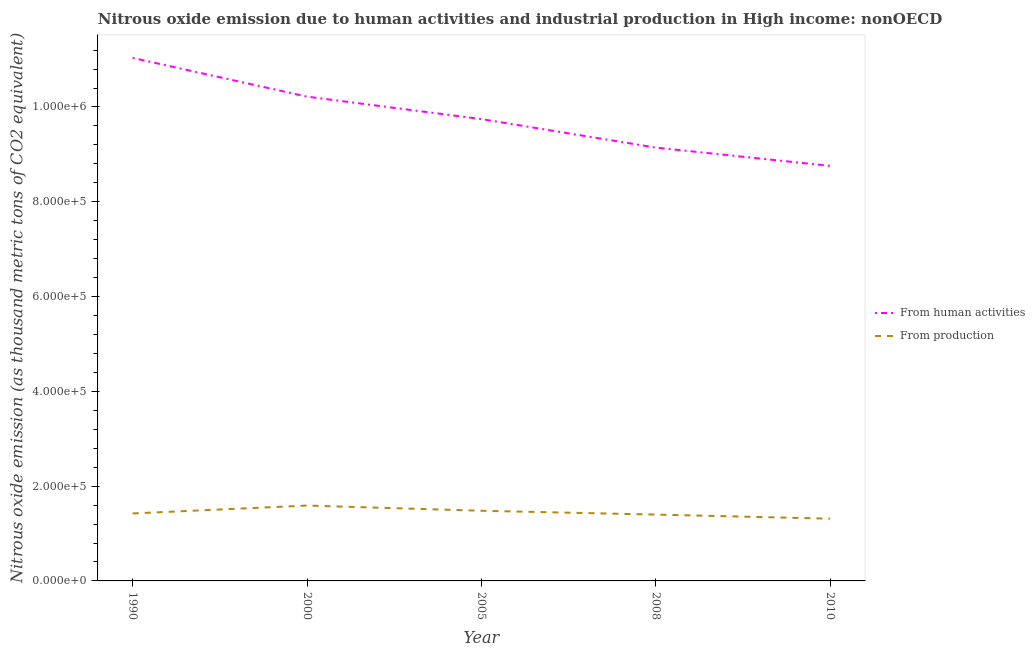Does the line corresponding to amount of emissions from human activities intersect with the line corresponding to amount of emissions generated from industries?
Make the answer very short. No. What is the amount of emissions generated from industries in 1990?
Give a very brief answer. 1.42e+05. Across all years, what is the maximum amount of emissions from human activities?
Your answer should be very brief. 1.10e+06. Across all years, what is the minimum amount of emissions from human activities?
Ensure brevity in your answer.  8.76e+05. In which year was the amount of emissions generated from industries maximum?
Your answer should be compact. 2000. What is the total amount of emissions generated from industries in the graph?
Offer a very short reply. 7.21e+05. What is the difference between the amount of emissions generated from industries in 2000 and that in 2008?
Offer a very short reply. 1.90e+04. What is the difference between the amount of emissions from human activities in 2010 and the amount of emissions generated from industries in 2000?
Offer a terse response. 7.17e+05. What is the average amount of emissions from human activities per year?
Your response must be concise. 9.78e+05. In the year 2000, what is the difference between the amount of emissions from human activities and amount of emissions generated from industries?
Provide a short and direct response. 8.63e+05. In how many years, is the amount of emissions generated from industries greater than 320000 thousand metric tons?
Make the answer very short. 0. What is the ratio of the amount of emissions generated from industries in 2000 to that in 2010?
Your answer should be very brief. 1.21. Is the difference between the amount of emissions generated from industries in 1990 and 2010 greater than the difference between the amount of emissions from human activities in 1990 and 2010?
Give a very brief answer. No. What is the difference between the highest and the second highest amount of emissions generated from industries?
Offer a very short reply. 1.10e+04. What is the difference between the highest and the lowest amount of emissions from human activities?
Offer a terse response. 2.28e+05. Does the amount of emissions from human activities monotonically increase over the years?
Provide a short and direct response. No. Is the amount of emissions from human activities strictly less than the amount of emissions generated from industries over the years?
Your answer should be very brief. No. How many lines are there?
Your answer should be compact. 2. Are the values on the major ticks of Y-axis written in scientific E-notation?
Ensure brevity in your answer.  Yes. Does the graph contain any zero values?
Your answer should be very brief. No. How many legend labels are there?
Provide a short and direct response. 2. How are the legend labels stacked?
Offer a very short reply. Vertical. What is the title of the graph?
Keep it short and to the point. Nitrous oxide emission due to human activities and industrial production in High income: nonOECD. Does "Exports" appear as one of the legend labels in the graph?
Your answer should be compact. No. What is the label or title of the Y-axis?
Your response must be concise. Nitrous oxide emission (as thousand metric tons of CO2 equivalent). What is the Nitrous oxide emission (as thousand metric tons of CO2 equivalent) of From human activities in 1990?
Your answer should be compact. 1.10e+06. What is the Nitrous oxide emission (as thousand metric tons of CO2 equivalent) of From production in 1990?
Keep it short and to the point. 1.42e+05. What is the Nitrous oxide emission (as thousand metric tons of CO2 equivalent) of From human activities in 2000?
Provide a short and direct response. 1.02e+06. What is the Nitrous oxide emission (as thousand metric tons of CO2 equivalent) of From production in 2000?
Offer a terse response. 1.59e+05. What is the Nitrous oxide emission (as thousand metric tons of CO2 equivalent) in From human activities in 2005?
Offer a very short reply. 9.74e+05. What is the Nitrous oxide emission (as thousand metric tons of CO2 equivalent) of From production in 2005?
Ensure brevity in your answer.  1.48e+05. What is the Nitrous oxide emission (as thousand metric tons of CO2 equivalent) in From human activities in 2008?
Offer a very short reply. 9.14e+05. What is the Nitrous oxide emission (as thousand metric tons of CO2 equivalent) in From production in 2008?
Offer a terse response. 1.40e+05. What is the Nitrous oxide emission (as thousand metric tons of CO2 equivalent) in From human activities in 2010?
Your answer should be very brief. 8.76e+05. What is the Nitrous oxide emission (as thousand metric tons of CO2 equivalent) in From production in 2010?
Provide a succinct answer. 1.31e+05. Across all years, what is the maximum Nitrous oxide emission (as thousand metric tons of CO2 equivalent) of From human activities?
Keep it short and to the point. 1.10e+06. Across all years, what is the maximum Nitrous oxide emission (as thousand metric tons of CO2 equivalent) in From production?
Ensure brevity in your answer.  1.59e+05. Across all years, what is the minimum Nitrous oxide emission (as thousand metric tons of CO2 equivalent) in From human activities?
Provide a short and direct response. 8.76e+05. Across all years, what is the minimum Nitrous oxide emission (as thousand metric tons of CO2 equivalent) of From production?
Give a very brief answer. 1.31e+05. What is the total Nitrous oxide emission (as thousand metric tons of CO2 equivalent) of From human activities in the graph?
Offer a terse response. 4.89e+06. What is the total Nitrous oxide emission (as thousand metric tons of CO2 equivalent) of From production in the graph?
Provide a succinct answer. 7.21e+05. What is the difference between the Nitrous oxide emission (as thousand metric tons of CO2 equivalent) of From human activities in 1990 and that in 2000?
Offer a terse response. 8.17e+04. What is the difference between the Nitrous oxide emission (as thousand metric tons of CO2 equivalent) of From production in 1990 and that in 2000?
Your response must be concise. -1.66e+04. What is the difference between the Nitrous oxide emission (as thousand metric tons of CO2 equivalent) in From human activities in 1990 and that in 2005?
Offer a very short reply. 1.29e+05. What is the difference between the Nitrous oxide emission (as thousand metric tons of CO2 equivalent) of From production in 1990 and that in 2005?
Your answer should be very brief. -5648.4. What is the difference between the Nitrous oxide emission (as thousand metric tons of CO2 equivalent) of From human activities in 1990 and that in 2008?
Offer a terse response. 1.89e+05. What is the difference between the Nitrous oxide emission (as thousand metric tons of CO2 equivalent) of From production in 1990 and that in 2008?
Your response must be concise. 2410.2. What is the difference between the Nitrous oxide emission (as thousand metric tons of CO2 equivalent) of From human activities in 1990 and that in 2010?
Ensure brevity in your answer.  2.28e+05. What is the difference between the Nitrous oxide emission (as thousand metric tons of CO2 equivalent) in From production in 1990 and that in 2010?
Your answer should be very brief. 1.11e+04. What is the difference between the Nitrous oxide emission (as thousand metric tons of CO2 equivalent) of From human activities in 2000 and that in 2005?
Make the answer very short. 4.74e+04. What is the difference between the Nitrous oxide emission (as thousand metric tons of CO2 equivalent) in From production in 2000 and that in 2005?
Make the answer very short. 1.10e+04. What is the difference between the Nitrous oxide emission (as thousand metric tons of CO2 equivalent) of From human activities in 2000 and that in 2008?
Your answer should be very brief. 1.08e+05. What is the difference between the Nitrous oxide emission (as thousand metric tons of CO2 equivalent) in From production in 2000 and that in 2008?
Offer a very short reply. 1.90e+04. What is the difference between the Nitrous oxide emission (as thousand metric tons of CO2 equivalent) in From human activities in 2000 and that in 2010?
Offer a terse response. 1.46e+05. What is the difference between the Nitrous oxide emission (as thousand metric tons of CO2 equivalent) of From production in 2000 and that in 2010?
Your answer should be very brief. 2.77e+04. What is the difference between the Nitrous oxide emission (as thousand metric tons of CO2 equivalent) in From human activities in 2005 and that in 2008?
Keep it short and to the point. 6.02e+04. What is the difference between the Nitrous oxide emission (as thousand metric tons of CO2 equivalent) of From production in 2005 and that in 2008?
Offer a terse response. 8058.6. What is the difference between the Nitrous oxide emission (as thousand metric tons of CO2 equivalent) of From human activities in 2005 and that in 2010?
Provide a short and direct response. 9.88e+04. What is the difference between the Nitrous oxide emission (as thousand metric tons of CO2 equivalent) in From production in 2005 and that in 2010?
Make the answer very short. 1.67e+04. What is the difference between the Nitrous oxide emission (as thousand metric tons of CO2 equivalent) in From human activities in 2008 and that in 2010?
Your answer should be compact. 3.86e+04. What is the difference between the Nitrous oxide emission (as thousand metric tons of CO2 equivalent) in From production in 2008 and that in 2010?
Your answer should be very brief. 8647.3. What is the difference between the Nitrous oxide emission (as thousand metric tons of CO2 equivalent) in From human activities in 1990 and the Nitrous oxide emission (as thousand metric tons of CO2 equivalent) in From production in 2000?
Your response must be concise. 9.45e+05. What is the difference between the Nitrous oxide emission (as thousand metric tons of CO2 equivalent) of From human activities in 1990 and the Nitrous oxide emission (as thousand metric tons of CO2 equivalent) of From production in 2005?
Make the answer very short. 9.55e+05. What is the difference between the Nitrous oxide emission (as thousand metric tons of CO2 equivalent) in From human activities in 1990 and the Nitrous oxide emission (as thousand metric tons of CO2 equivalent) in From production in 2008?
Offer a very short reply. 9.64e+05. What is the difference between the Nitrous oxide emission (as thousand metric tons of CO2 equivalent) in From human activities in 1990 and the Nitrous oxide emission (as thousand metric tons of CO2 equivalent) in From production in 2010?
Provide a succinct answer. 9.72e+05. What is the difference between the Nitrous oxide emission (as thousand metric tons of CO2 equivalent) of From human activities in 2000 and the Nitrous oxide emission (as thousand metric tons of CO2 equivalent) of From production in 2005?
Your answer should be very brief. 8.74e+05. What is the difference between the Nitrous oxide emission (as thousand metric tons of CO2 equivalent) of From human activities in 2000 and the Nitrous oxide emission (as thousand metric tons of CO2 equivalent) of From production in 2008?
Offer a terse response. 8.82e+05. What is the difference between the Nitrous oxide emission (as thousand metric tons of CO2 equivalent) in From human activities in 2000 and the Nitrous oxide emission (as thousand metric tons of CO2 equivalent) in From production in 2010?
Provide a short and direct response. 8.90e+05. What is the difference between the Nitrous oxide emission (as thousand metric tons of CO2 equivalent) of From human activities in 2005 and the Nitrous oxide emission (as thousand metric tons of CO2 equivalent) of From production in 2008?
Offer a very short reply. 8.34e+05. What is the difference between the Nitrous oxide emission (as thousand metric tons of CO2 equivalent) of From human activities in 2005 and the Nitrous oxide emission (as thousand metric tons of CO2 equivalent) of From production in 2010?
Your response must be concise. 8.43e+05. What is the difference between the Nitrous oxide emission (as thousand metric tons of CO2 equivalent) of From human activities in 2008 and the Nitrous oxide emission (as thousand metric tons of CO2 equivalent) of From production in 2010?
Offer a very short reply. 7.83e+05. What is the average Nitrous oxide emission (as thousand metric tons of CO2 equivalent) of From human activities per year?
Your answer should be very brief. 9.78e+05. What is the average Nitrous oxide emission (as thousand metric tons of CO2 equivalent) of From production per year?
Offer a terse response. 1.44e+05. In the year 1990, what is the difference between the Nitrous oxide emission (as thousand metric tons of CO2 equivalent) of From human activities and Nitrous oxide emission (as thousand metric tons of CO2 equivalent) of From production?
Your answer should be compact. 9.61e+05. In the year 2000, what is the difference between the Nitrous oxide emission (as thousand metric tons of CO2 equivalent) in From human activities and Nitrous oxide emission (as thousand metric tons of CO2 equivalent) in From production?
Keep it short and to the point. 8.63e+05. In the year 2005, what is the difference between the Nitrous oxide emission (as thousand metric tons of CO2 equivalent) in From human activities and Nitrous oxide emission (as thousand metric tons of CO2 equivalent) in From production?
Your answer should be very brief. 8.26e+05. In the year 2008, what is the difference between the Nitrous oxide emission (as thousand metric tons of CO2 equivalent) of From human activities and Nitrous oxide emission (as thousand metric tons of CO2 equivalent) of From production?
Offer a very short reply. 7.74e+05. In the year 2010, what is the difference between the Nitrous oxide emission (as thousand metric tons of CO2 equivalent) in From human activities and Nitrous oxide emission (as thousand metric tons of CO2 equivalent) in From production?
Your answer should be very brief. 7.44e+05. What is the ratio of the Nitrous oxide emission (as thousand metric tons of CO2 equivalent) of From production in 1990 to that in 2000?
Provide a succinct answer. 0.9. What is the ratio of the Nitrous oxide emission (as thousand metric tons of CO2 equivalent) of From human activities in 1990 to that in 2005?
Keep it short and to the point. 1.13. What is the ratio of the Nitrous oxide emission (as thousand metric tons of CO2 equivalent) of From production in 1990 to that in 2005?
Offer a terse response. 0.96. What is the ratio of the Nitrous oxide emission (as thousand metric tons of CO2 equivalent) of From human activities in 1990 to that in 2008?
Offer a very short reply. 1.21. What is the ratio of the Nitrous oxide emission (as thousand metric tons of CO2 equivalent) in From production in 1990 to that in 2008?
Keep it short and to the point. 1.02. What is the ratio of the Nitrous oxide emission (as thousand metric tons of CO2 equivalent) of From human activities in 1990 to that in 2010?
Provide a succinct answer. 1.26. What is the ratio of the Nitrous oxide emission (as thousand metric tons of CO2 equivalent) of From production in 1990 to that in 2010?
Offer a terse response. 1.08. What is the ratio of the Nitrous oxide emission (as thousand metric tons of CO2 equivalent) of From human activities in 2000 to that in 2005?
Your answer should be compact. 1.05. What is the ratio of the Nitrous oxide emission (as thousand metric tons of CO2 equivalent) in From production in 2000 to that in 2005?
Your answer should be compact. 1.07. What is the ratio of the Nitrous oxide emission (as thousand metric tons of CO2 equivalent) in From human activities in 2000 to that in 2008?
Your response must be concise. 1.12. What is the ratio of the Nitrous oxide emission (as thousand metric tons of CO2 equivalent) in From production in 2000 to that in 2008?
Your answer should be very brief. 1.14. What is the ratio of the Nitrous oxide emission (as thousand metric tons of CO2 equivalent) in From human activities in 2000 to that in 2010?
Your answer should be compact. 1.17. What is the ratio of the Nitrous oxide emission (as thousand metric tons of CO2 equivalent) in From production in 2000 to that in 2010?
Provide a succinct answer. 1.21. What is the ratio of the Nitrous oxide emission (as thousand metric tons of CO2 equivalent) in From human activities in 2005 to that in 2008?
Your response must be concise. 1.07. What is the ratio of the Nitrous oxide emission (as thousand metric tons of CO2 equivalent) of From production in 2005 to that in 2008?
Your answer should be compact. 1.06. What is the ratio of the Nitrous oxide emission (as thousand metric tons of CO2 equivalent) of From human activities in 2005 to that in 2010?
Your response must be concise. 1.11. What is the ratio of the Nitrous oxide emission (as thousand metric tons of CO2 equivalent) of From production in 2005 to that in 2010?
Keep it short and to the point. 1.13. What is the ratio of the Nitrous oxide emission (as thousand metric tons of CO2 equivalent) of From human activities in 2008 to that in 2010?
Offer a very short reply. 1.04. What is the ratio of the Nitrous oxide emission (as thousand metric tons of CO2 equivalent) of From production in 2008 to that in 2010?
Give a very brief answer. 1.07. What is the difference between the highest and the second highest Nitrous oxide emission (as thousand metric tons of CO2 equivalent) of From human activities?
Your response must be concise. 8.17e+04. What is the difference between the highest and the second highest Nitrous oxide emission (as thousand metric tons of CO2 equivalent) of From production?
Your response must be concise. 1.10e+04. What is the difference between the highest and the lowest Nitrous oxide emission (as thousand metric tons of CO2 equivalent) in From human activities?
Give a very brief answer. 2.28e+05. What is the difference between the highest and the lowest Nitrous oxide emission (as thousand metric tons of CO2 equivalent) of From production?
Offer a terse response. 2.77e+04. 